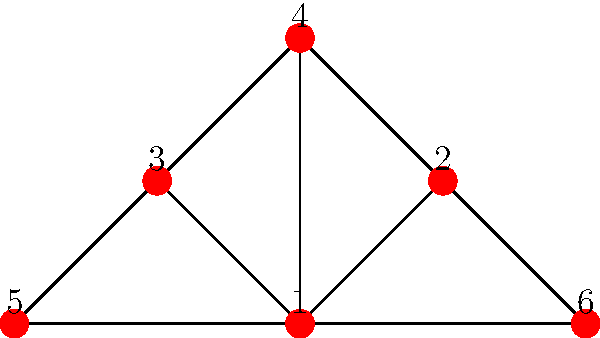The graph represents the social network structure of student support groups on campus. Each node represents a support group, and edges represent connections between groups. Which node has the highest degree centrality, and what implications might this have for the flow of information and resources among student support groups? To answer this question, we need to follow these steps:

1. Understand degree centrality:
   Degree centrality is a measure of the number of direct connections a node has in a network.

2. Count the connections for each node:
   Node 1: 5 connections
   Node 2: 3 connections
   Node 3: 3 connections
   Node 4: 3 connections
   Node 5: 2 connections
   Node 6: 2 connections

3. Identify the node with the highest degree centrality:
   Node 1 has the highest degree centrality with 5 connections.

4. Interpret the implications:
   a) Information flow: Node 1 has the most direct connections, meaning it can quickly disseminate information to or receive information from many other groups.
   b) Resource sharing: This node is in the best position to facilitate resource sharing among different support groups.
   c) Coordination: Node 1 could play a crucial role in coordinating activities or initiatives across multiple support groups.
   d) Influence: This node likely has significant influence in the network due to its many connections.
   e) Vulnerability: If Node 1 were to be removed or become inactive, it could significantly disrupt the network's structure and functionality.

5. Consider the limitations:
   While degree centrality is important, other factors like the quality of connections and the specific roles of each group should also be considered for a comprehensive understanding of the network's dynamics.
Answer: Node 1 has the highest degree centrality, implying it's a key hub for information flow, resource sharing, and coordination among student support groups. 